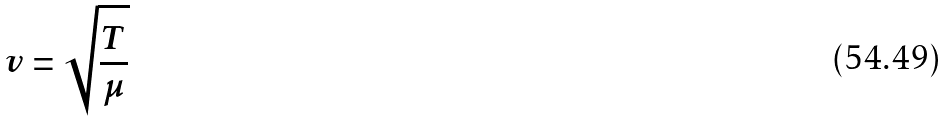Convert formula to latex. <formula><loc_0><loc_0><loc_500><loc_500>v = \sqrt { \frac { T } { \mu } }</formula> 